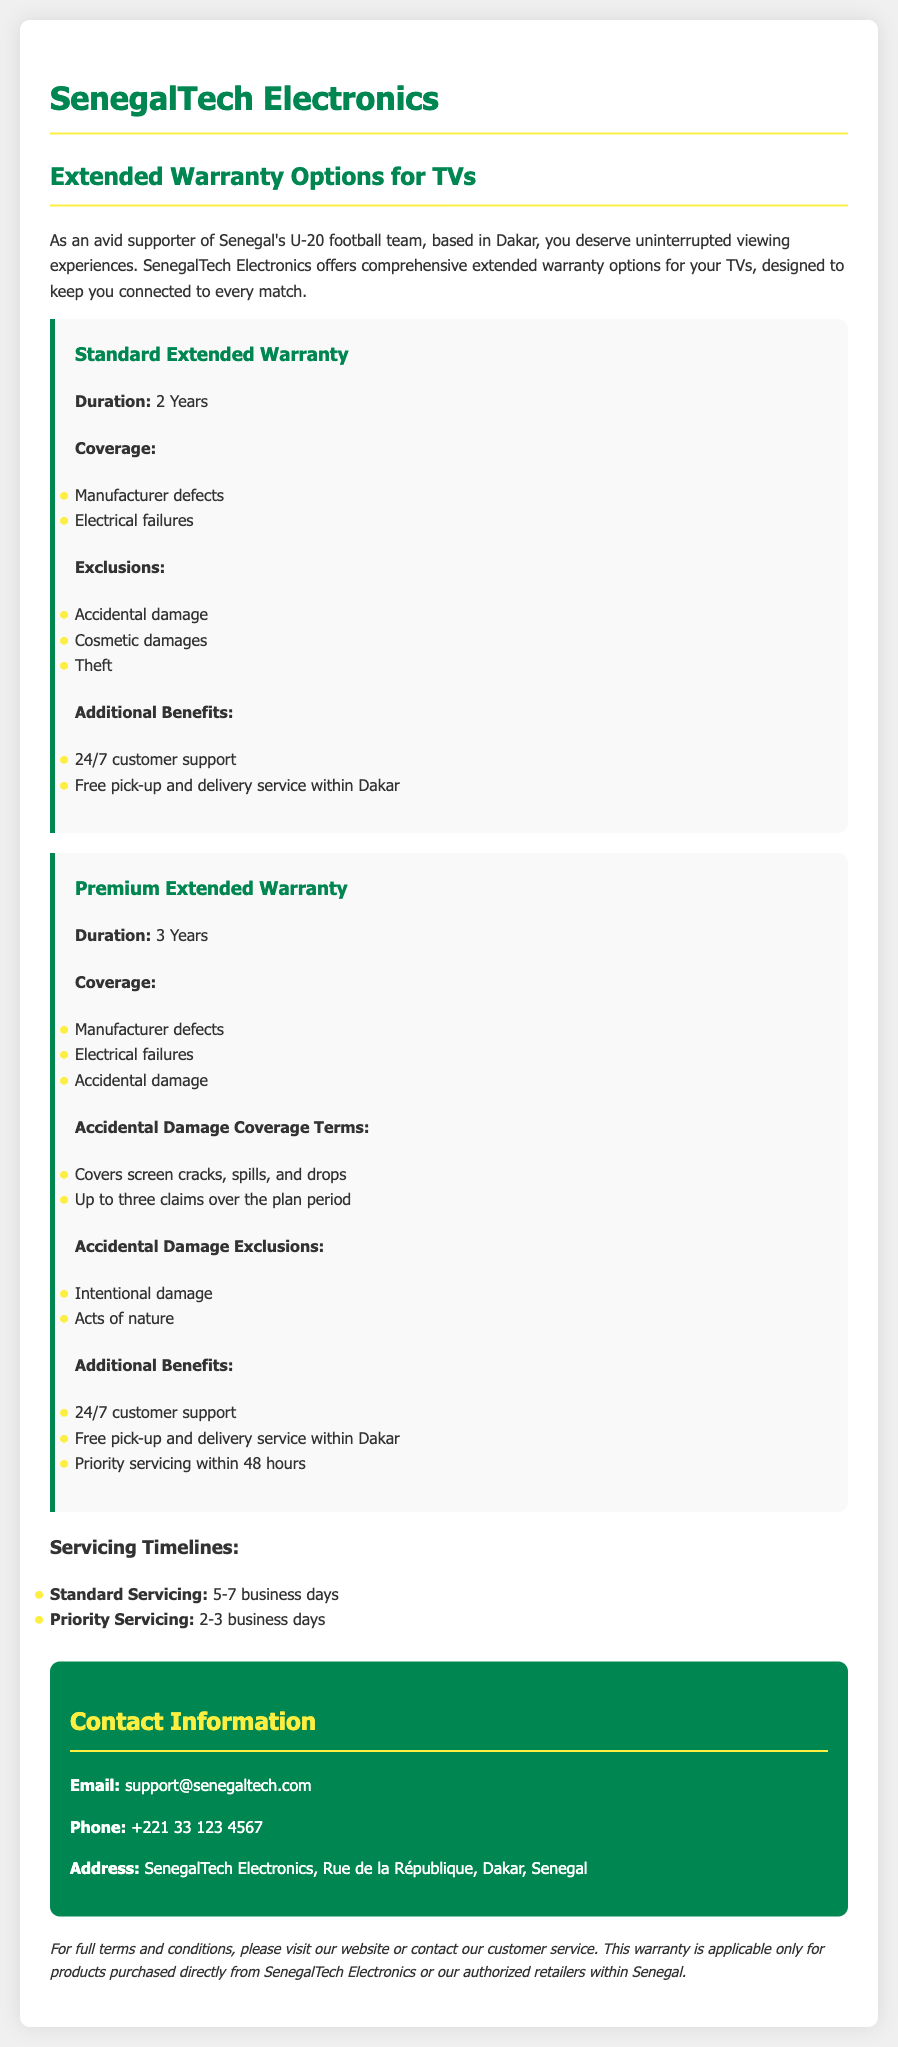What is the duration of the Standard Extended Warranty? The duration of the Standard Extended Warranty is specified in the document.
Answer: 2 Years What additional benefit is included in the Premium Extended Warranty? The document lists benefits associated with the Premium Extended Warranty, including customer support.
Answer: Priority servicing within 48 hours How many claims are allowed for accidental damage coverage under the Premium Extended Warranty? The document mentions the limit on claims for accidental damage coverage.
Answer: Up to three claims What is the contact email for SenegalTech Electronics? The document provides the contact information, specifically the email address.
Answer: support@senegaltech.com What is excluded from the Standard Extended Warranty coverage? The document details the exclusions in the Standard Extended Warranty.
Answer: Accidental damage What is the standard servicing timeline as per the document? The document specifies the business days required for standard servicing.
Answer: 5-7 business days What type of damage is covered under the Premium Extended Warranty? The document lists different types of coverage under the Premium Extended Warranty.
Answer: Accidental damage What is the address of SenegalTech Electronics? The document includes the physical address of the company as contact information.
Answer: Rue de la République, Dakar, Senegal 